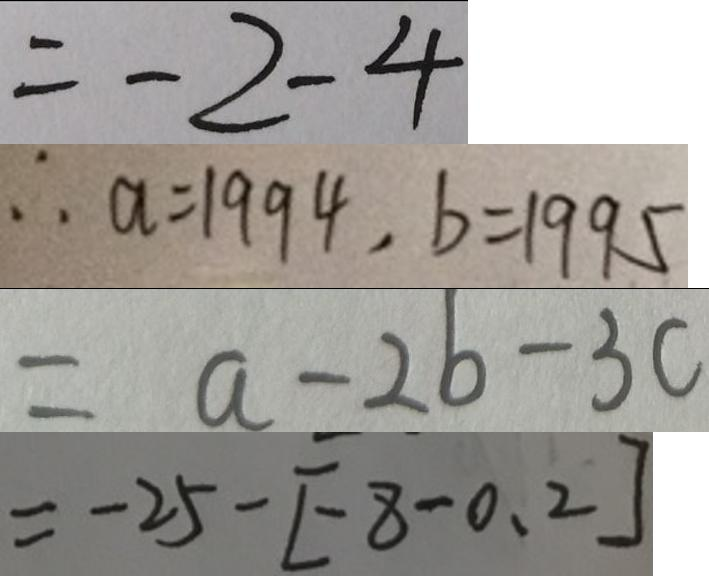Convert formula to latex. <formula><loc_0><loc_0><loc_500><loc_500>= - 2 - 4 
 \therefore a = 1 9 9 4 , b = 1 9 9 5 
 = a - 2 b - 3 c 
 = - 2 5 - [ - 8 - 0 . 2 ]</formula> 